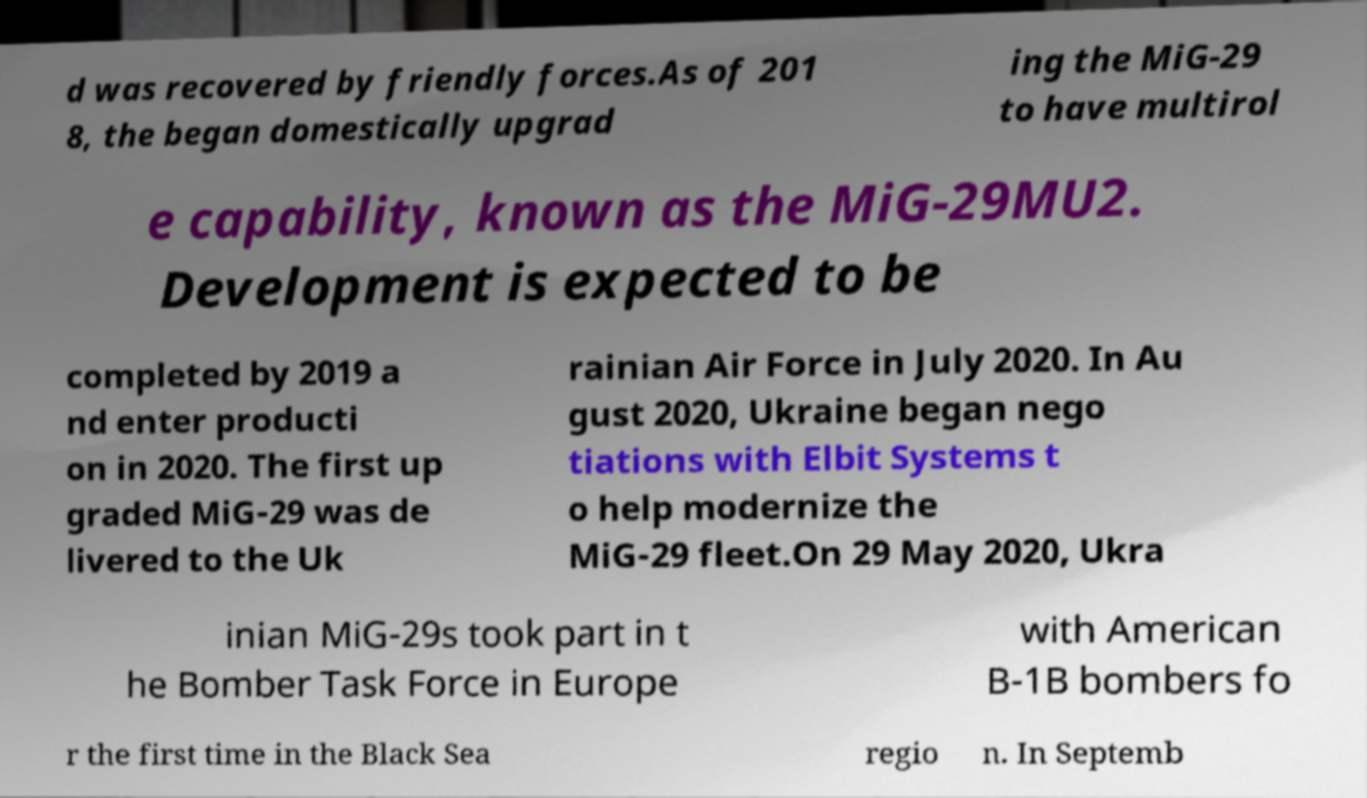Could you extract and type out the text from this image? d was recovered by friendly forces.As of 201 8, the began domestically upgrad ing the MiG-29 to have multirol e capability, known as the MiG-29MU2. Development is expected to be completed by 2019 a nd enter producti on in 2020. The first up graded MiG-29 was de livered to the Uk rainian Air Force in July 2020. In Au gust 2020, Ukraine began nego tiations with Elbit Systems t o help modernize the MiG-29 fleet.On 29 May 2020, Ukra inian MiG-29s took part in t he Bomber Task Force in Europe with American B-1B bombers fo r the first time in the Black Sea regio n. In Septemb 